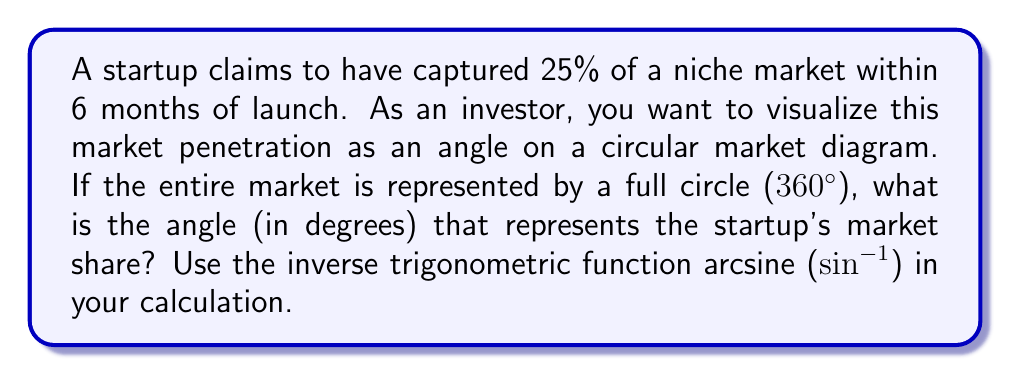Teach me how to tackle this problem. To solve this problem, we need to follow these steps:

1) First, let's understand what 25% means in terms of a circle. In a full circle:
   - 100% = 360°
   - 25% = 90° (which is a quarter of a circle)

2) Now, we need to use the arcsine function to find this angle. In a unit circle, sine of an angle is equal to the y-coordinate of the point where the angle's terminal side intersects the circle.

3) For a 90° angle in a unit circle, the y-coordinate is 1. So we need to find:

   $$\theta = \sin^{-1}(1)$$

4) However, this would give us the angle in radians. To convert to degrees, we multiply by (180/π):

   $$\theta_{degrees} = \sin^{-1}(1) \cdot \frac{180}{\pi}$$

5) Calculating this:
   $$\theta_{degrees} = 90°$$

This confirms our initial understanding that 25% of a circle is indeed 90°.

[asy]
unitsize(2cm);
draw(circle((0,0),1));
draw((0,0)--(1,0),arrow=Arrow(TeXHead));
draw((0,0)--(0,1),arrow=Arrow(TeXHead));
label("90°", (0.3,0.3));
draw((1,0)..(0.7,0.7)..(0,1),dashed);
[/asy]

The diagram above illustrates a quarter of the circle, representing the 25% market share.
Answer: The angle representing the startup's 25% market share is 90°. 